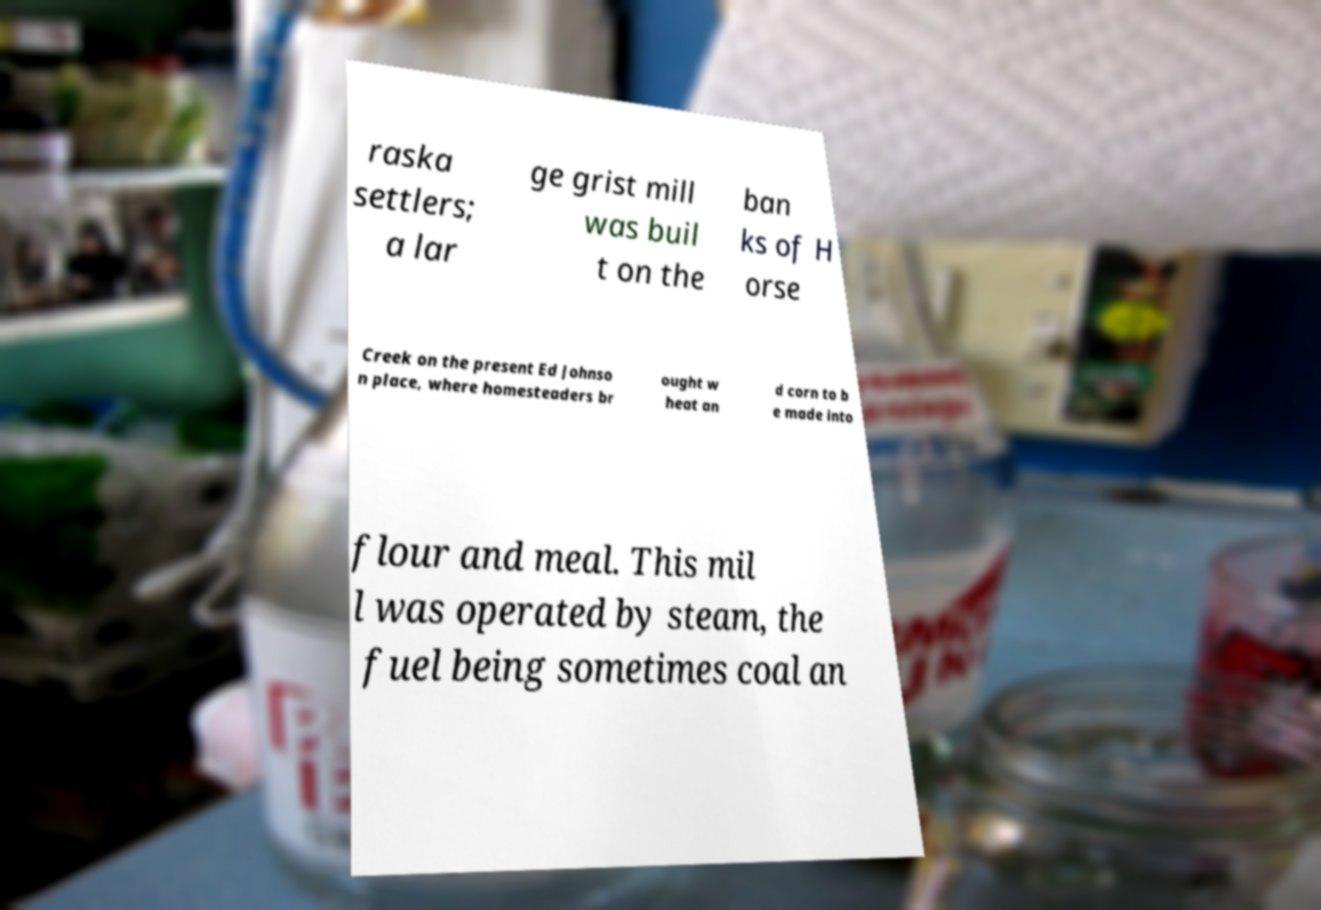For documentation purposes, I need the text within this image transcribed. Could you provide that? raska settlers; a lar ge grist mill was buil t on the ban ks of H orse Creek on the present Ed Johnso n place, where homesteaders br ought w heat an d corn to b e made into flour and meal. This mil l was operated by steam, the fuel being sometimes coal an 